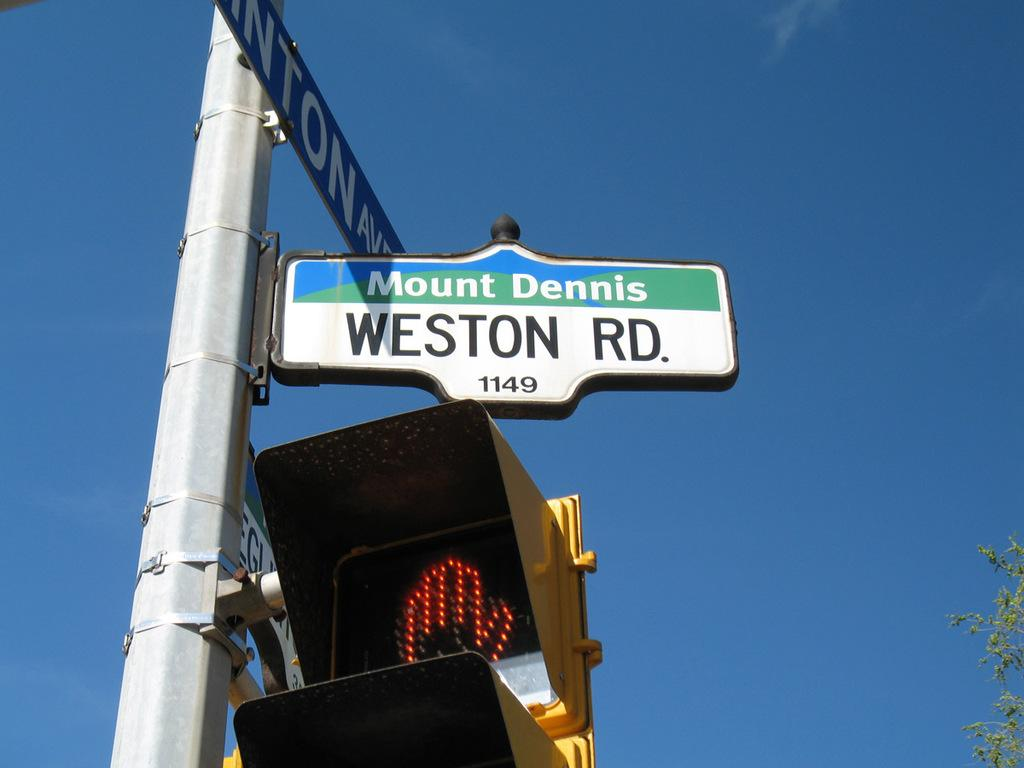<image>
Present a compact description of the photo's key features. A street sign saying Mount Dennis Weston Road stands above a traffic light. 